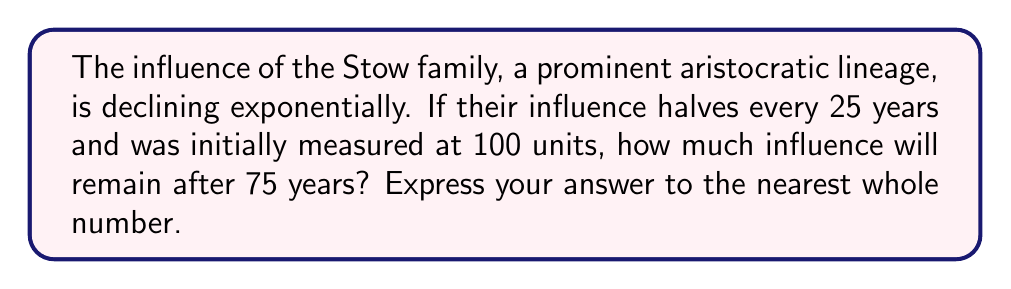Solve this math problem. Let's approach this step-by-step using the exponential decay model:

1) The general form of exponential decay is:
   $$A(t) = A_0 \cdot e^{-kt}$$
   where $A(t)$ is the amount at time $t$, $A_0$ is the initial amount, $k$ is the decay constant, and $t$ is time.

2) We're told that the influence halves every 25 years. We can use this to find $k$:
   $$\frac{1}{2} = e^{-25k}$$

3) Taking natural log of both sides:
   $$\ln(\frac{1}{2}) = -25k$$
   $$k = \frac{\ln(2)}{25} \approx 0.0277$$

4) Now we have all the components for our model:
   $A_0 = 100$ (initial influence)
   $k = 0.0277$
   $t = 75$ years

5) Plugging into our exponential decay formula:
   $$A(75) = 100 \cdot e^{-0.0277 \cdot 75}$$

6) Calculate:
   $$A(75) = 100 \cdot e^{-2.0775} \approx 12.5$$

7) Rounding to the nearest whole number: 13
Answer: 13 units 